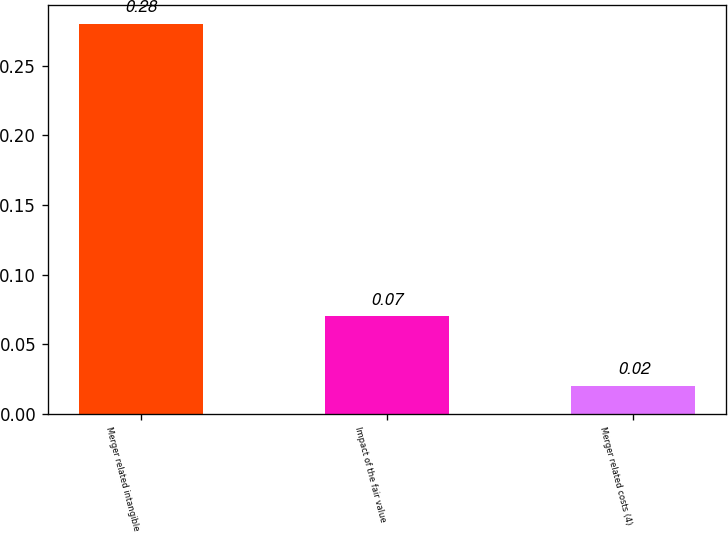Convert chart to OTSL. <chart><loc_0><loc_0><loc_500><loc_500><bar_chart><fcel>Merger related intangible<fcel>Impact of the fair value<fcel>Merger related costs (4)<nl><fcel>0.28<fcel>0.07<fcel>0.02<nl></chart> 